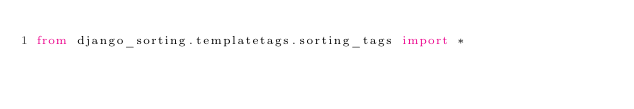<code> <loc_0><loc_0><loc_500><loc_500><_Python_>from django_sorting.templatetags.sorting_tags import *
</code> 